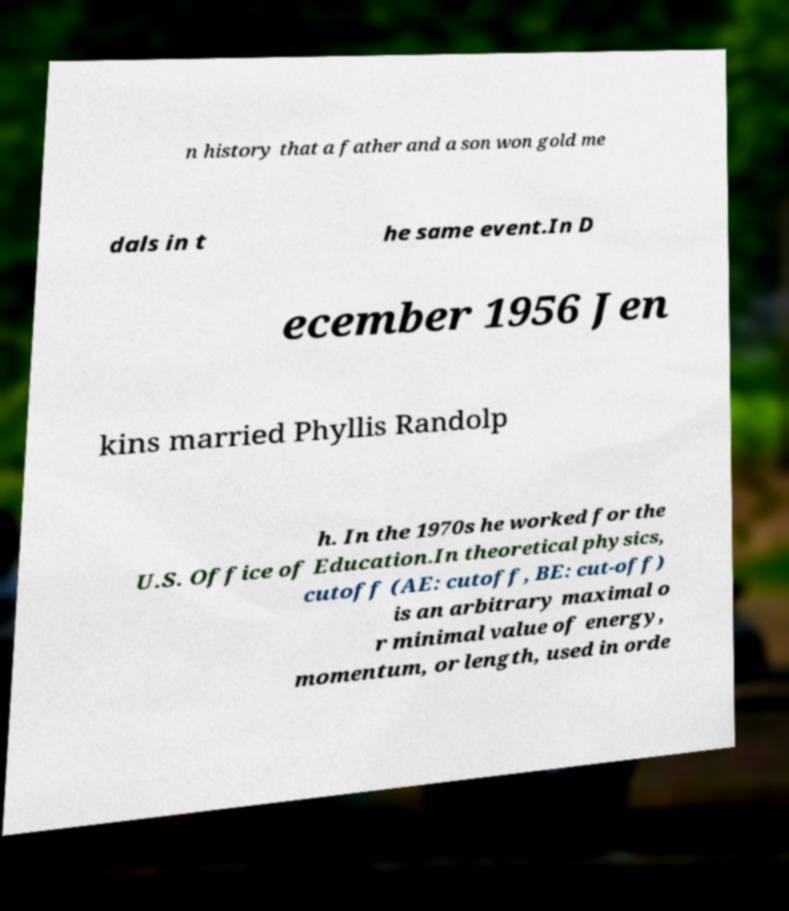Could you extract and type out the text from this image? n history that a father and a son won gold me dals in t he same event.In D ecember 1956 Jen kins married Phyllis Randolp h. In the 1970s he worked for the U.S. Office of Education.In theoretical physics, cutoff (AE: cutoff, BE: cut-off) is an arbitrary maximal o r minimal value of energy, momentum, or length, used in orde 